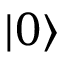Convert formula to latex. <formula><loc_0><loc_0><loc_500><loc_500>| 0 \rangle</formula> 